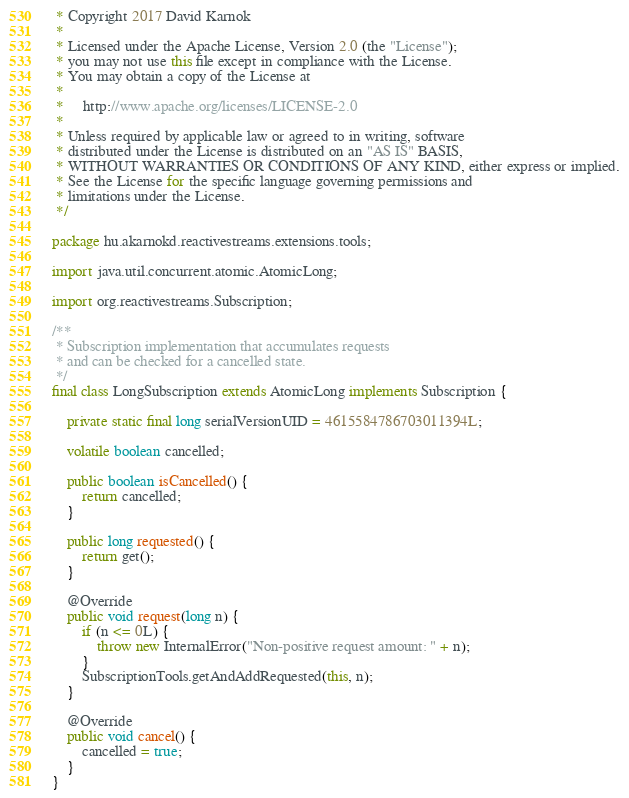Convert code to text. <code><loc_0><loc_0><loc_500><loc_500><_Java_> * Copyright 2017 David Karnok
 *
 * Licensed under the Apache License, Version 2.0 (the "License");
 * you may not use this file except in compliance with the License.
 * You may obtain a copy of the License at
 *
 *     http://www.apache.org/licenses/LICENSE-2.0
 *
 * Unless required by applicable law or agreed to in writing, software
 * distributed under the License is distributed on an "AS IS" BASIS,
 * WITHOUT WARRANTIES OR CONDITIONS OF ANY KIND, either express or implied.
 * See the License for the specific language governing permissions and
 * limitations under the License.
 */

package hu.akarnokd.reactivestreams.extensions.tools;

import java.util.concurrent.atomic.AtomicLong;

import org.reactivestreams.Subscription;

/**
 * Subscription implementation that accumulates requests
 * and can be checked for a cancelled state.
 */
final class LongSubscription extends AtomicLong implements Subscription {

    private static final long serialVersionUID = 4615584786703011394L;

    volatile boolean cancelled;

    public boolean isCancelled() {
        return cancelled;
    }

    public long requested() {
        return get();
    }

    @Override
    public void request(long n) {
        if (n <= 0L) {
            throw new InternalError("Non-positive request amount: " + n);
        }
        SubscriptionTools.getAndAddRequested(this, n);
    }

    @Override
    public void cancel() {
        cancelled = true;
    }
}
</code> 